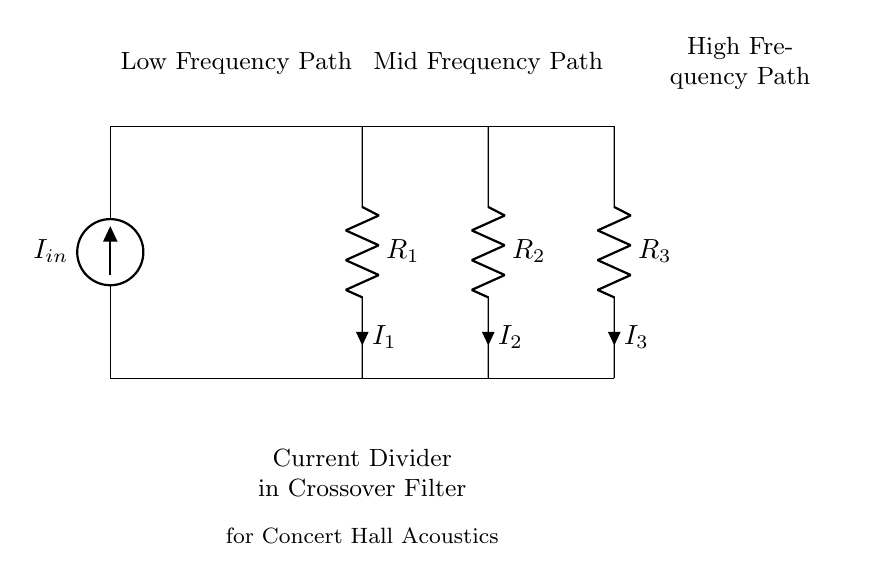What is the total number of resistors in the circuit? The circuit diagram displays three resistors, labeled R1, R2, and R3, connected in parallel to form the current divider.
Answer: 3 What is the purpose of this circuit diagram? The purpose of this diagram is to illustrate a current divider configuration specifically designed for a crossover filter in sound systems, optimizing concert hall acoustics by directing different frequency signals to appropriate speakers.
Answer: Current divider in crossover filter What is the current entering the circuit labeled as? The incoming current is indicated in the circuit by the symbol I_in, which represents the total current supplied to the circuit.
Answer: I_in Which resistor has the highest voltage drop across it? In a current divider, the voltage drop across each resistor can be inferred as equal to the input current times the resistance. If R1, R2, and R3 have different values, the one with the highest resistance would experience the highest voltage drop. If equal, they share the voltage evenly.
Answer: Depends on resistor values How many paths does the current take in this circuit? The configuration illustrates that the current can take three distinct paths, through R1, R2, and R3, allowing for distribution of the total input current to different frequency ranges.
Answer: 3 What type of filter does this current divider represent? The current divider here represents a crossover filter, which is used to separate audio signals into different frequency ranges for further processing and amplification.
Answer: Crossover filter 